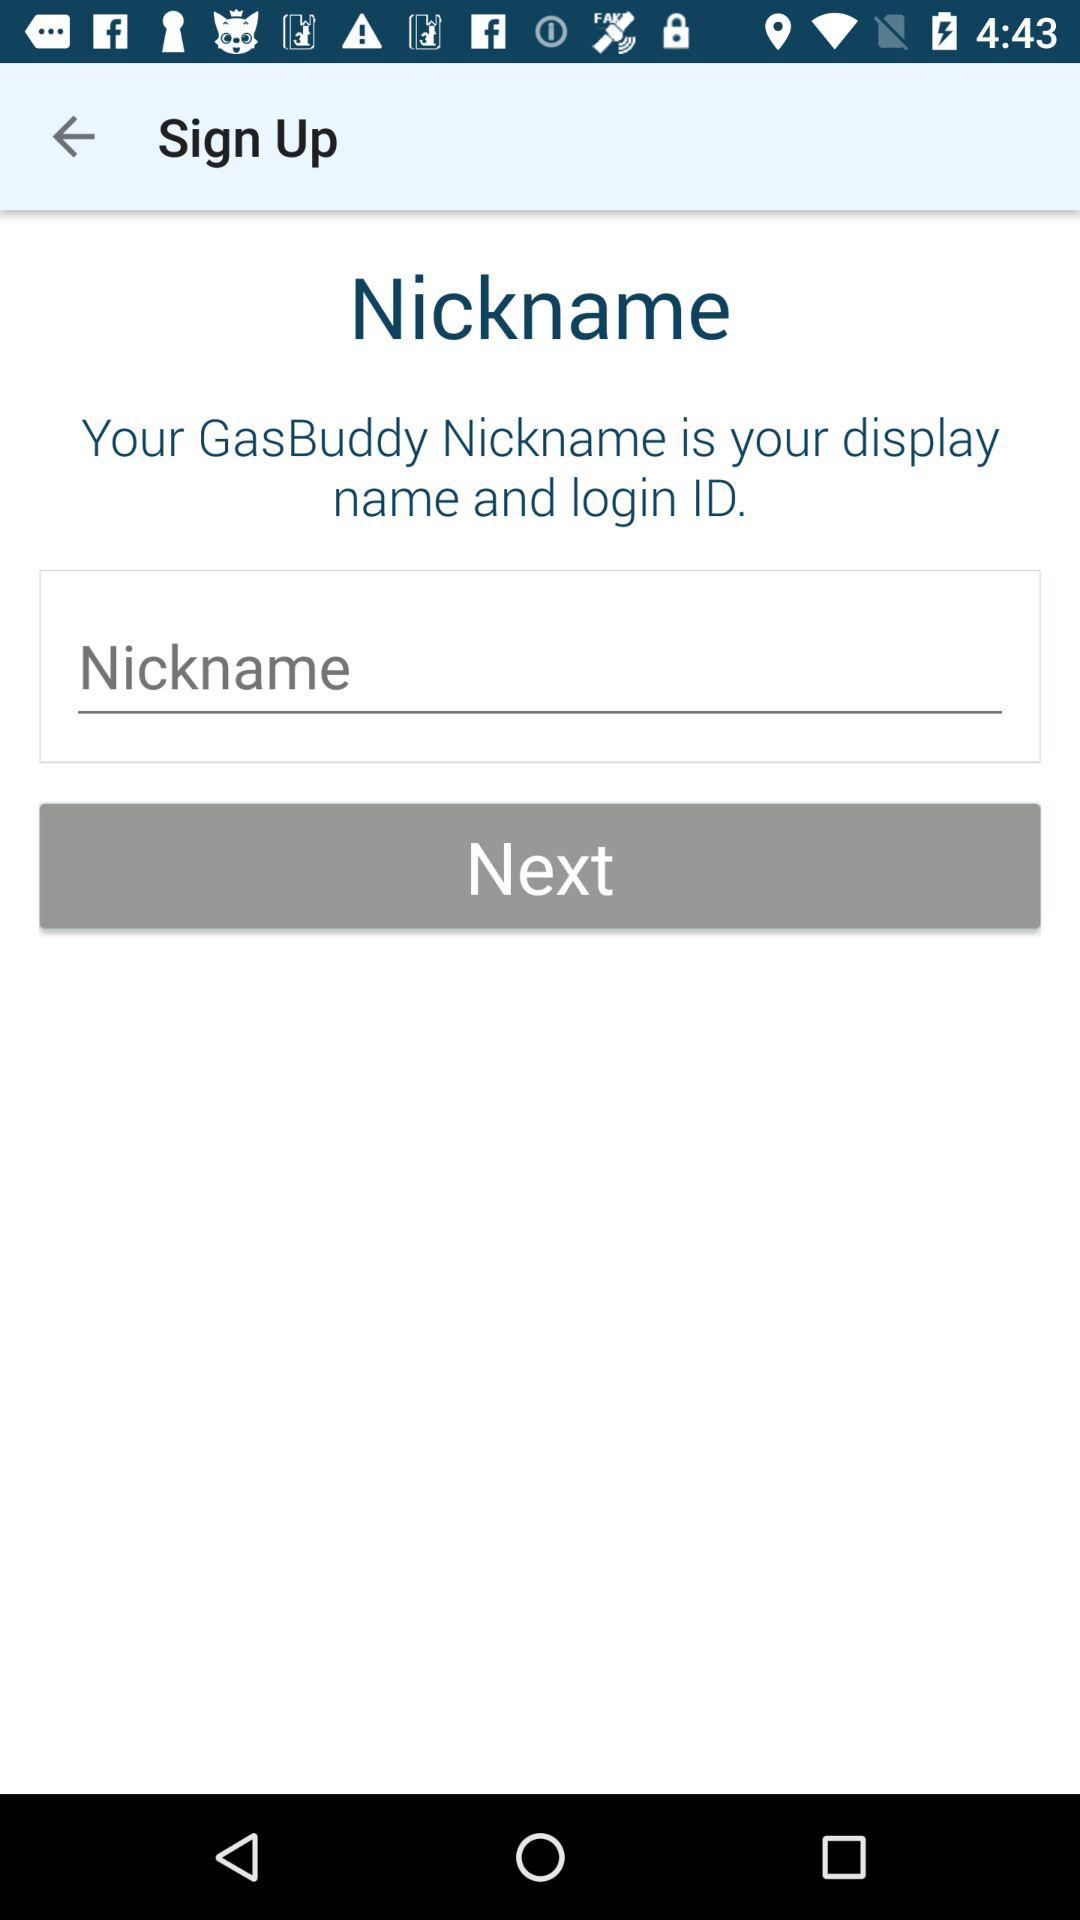What's the user nickname? The user nickname is "Nickname". 